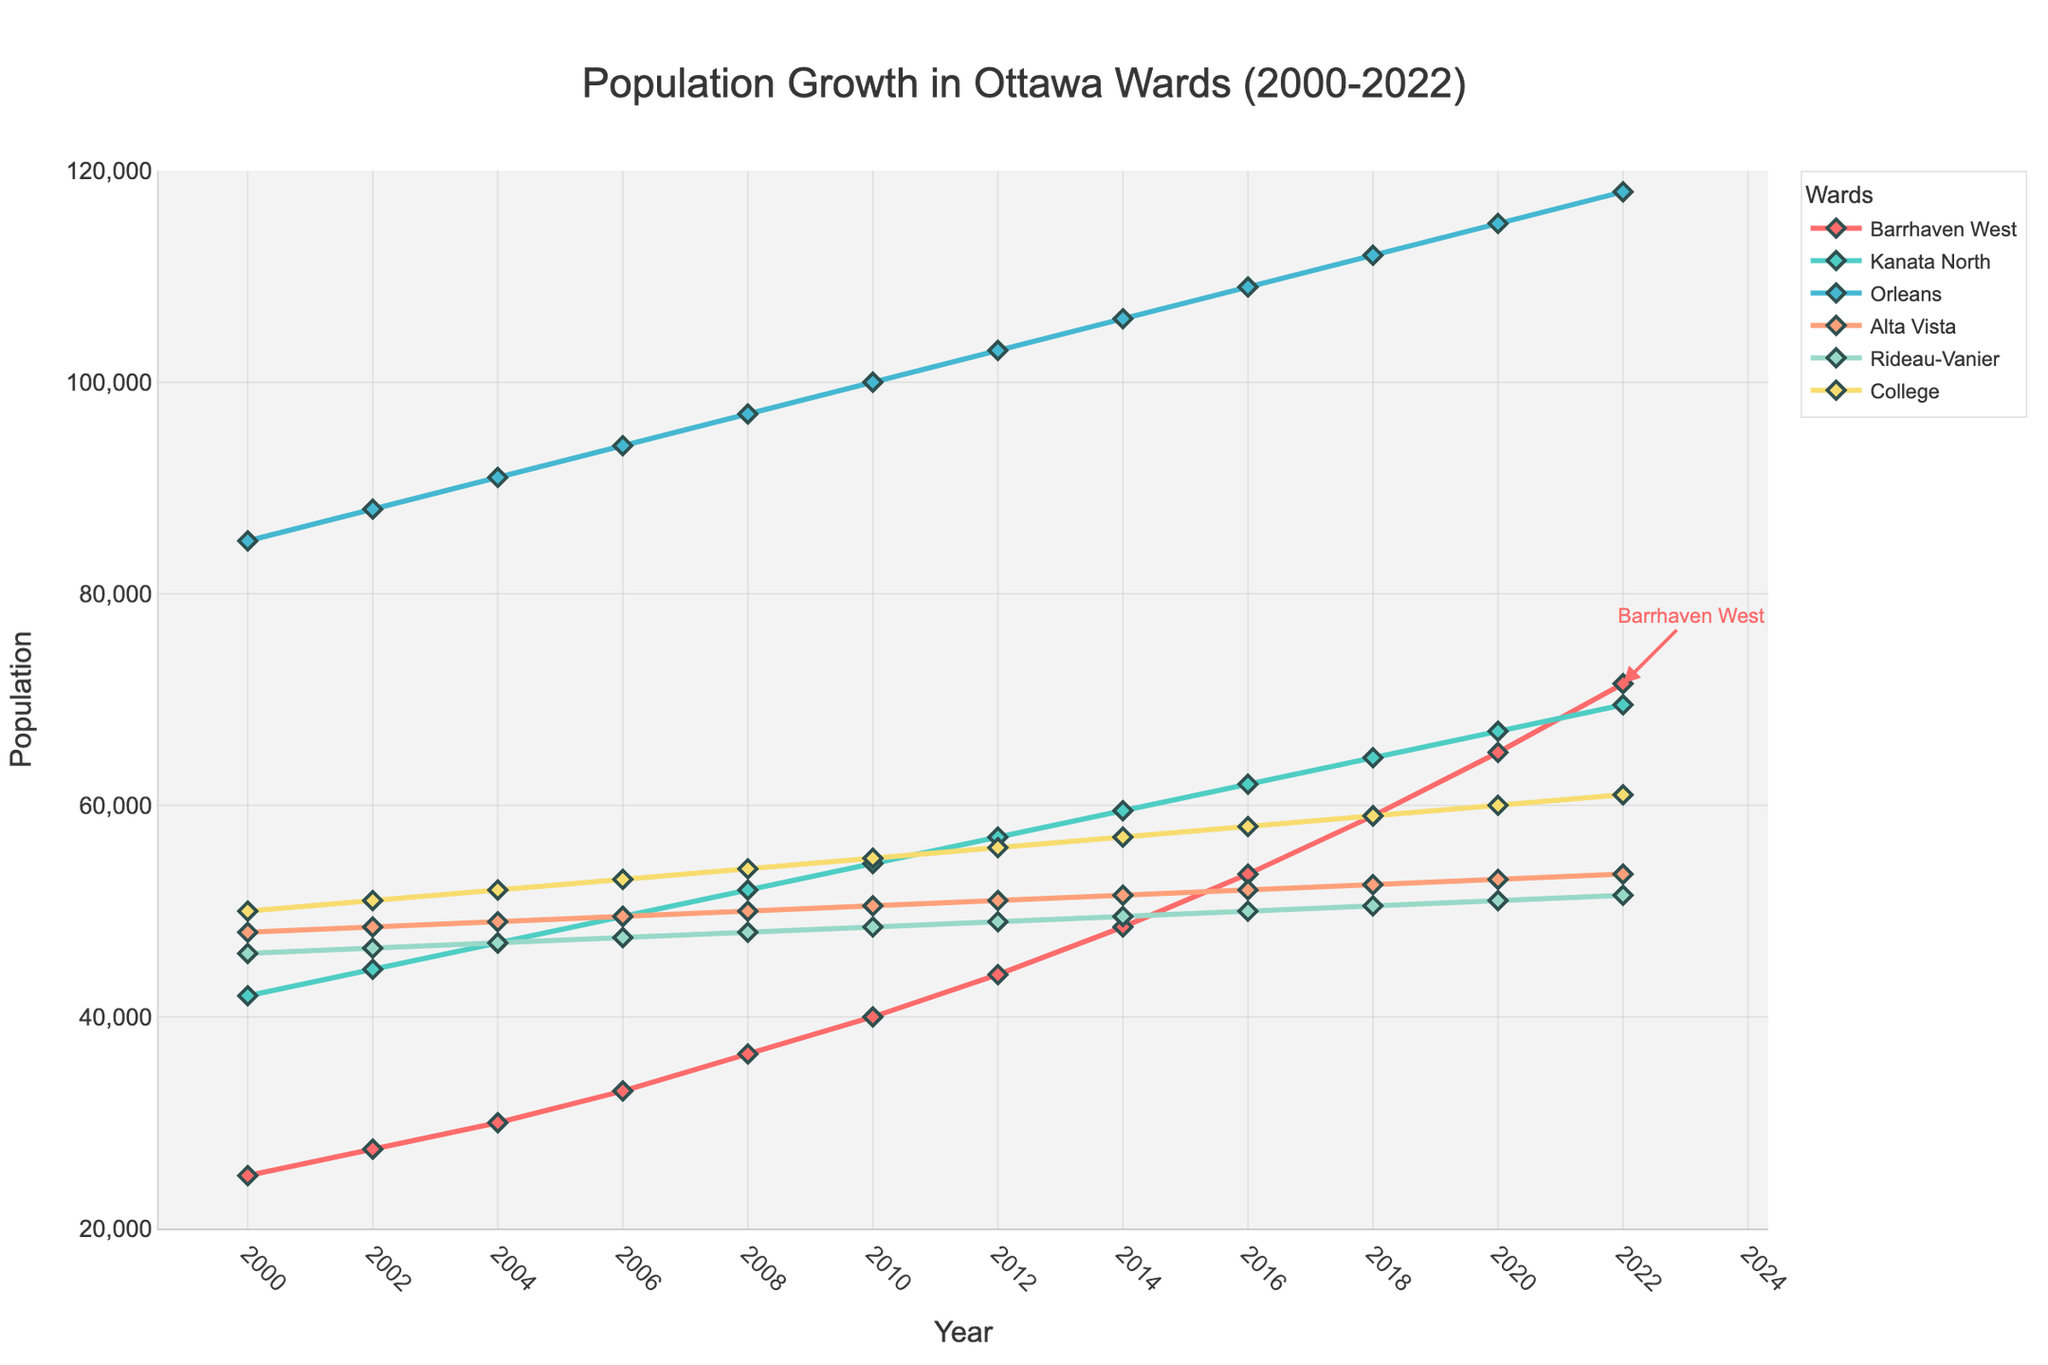What's the population growth rate of Barrhaven West from 2000 to 2022? To find the growth rate, subtract the population in 2000 from the population in 2022 and divide by the population in 2000. Multiply by 100 to get the percentage. (71500 - 25000) / 25000 * 100
Answer: 186% Which ward had the highest population in 2022? To determine this, look at the population numbers for all wards in 2022. The highest value is 118000 for Orleans.
Answer: Orleans How does the population of Kanata North in 2002 compare to that in 2022? Compare the population values directly from the plot. In 2002, Kanata North had 44500 people, and in 2022, it had 69500 people. 69500 is greater than 44500, so it increased.
Answer: Increased Among Barrhaven West, Kanata North, and College, which ward had the smallest population in 2010? Check the population values for 2010 for these three wards. Barrhaven West had 40000, Kanata North had 54500, and College had 55000. The smallest is 40000 for Barrhaven West.
Answer: Barrhaven West What's the average population of Orleans over the years presented? Sum the population values of Orleans from all the years and divide by the number of years (12). (85000 + 88000 + 91000 + 94000 + 97000 + 100000 + 103000 + 106000 + 109000 + 112000 + 115000 + 118000) / 12 = 101083.33
Answer: 101083.33 Which ward had the least growth from 2000 to 2022? Subtract the population of each ward in 2000 from the population in 2022 and determine which one has the least difference. Alta Vista has grown from 48000 to 53500, so (53500 - 48000) = 5500, the smallest difference among the wards.
Answer: Alta Vista How does the population trend of Barrhaven West compare to the trend in Rideau-Vanier? Visualize the slopes of the lines representing Barrhaven West and Rideau-Vanier. Barrhaven West shows a steep, consistent upward trend, whereas Rideau-Vanier's line is nearly flat, indicating minimal growth.
Answer: Barrhaven West shows more growth What is the difference in population between Orleans and College in 2022? Subtract the population of College from Orleans in 2022. Orleans had 118000 and College had 61000. 118000 - 61000 = 57000
Answer: 57000 Find the year when Barrhaven West crossed 50000 in population. Look for the point where the population of Barrhaven West exceeds 50000. It happens between 2014 (48500) and 2016 (53500). The year is 2016.
Answer: 2016 Calculate the average growth per year for Barrhaven West from 2000 to 2022. Subtract the population in 2000 from 2022 and divide by the number of years (22). (71500 - 25000) / 22 = 2113.64
Answer: 2113.64 